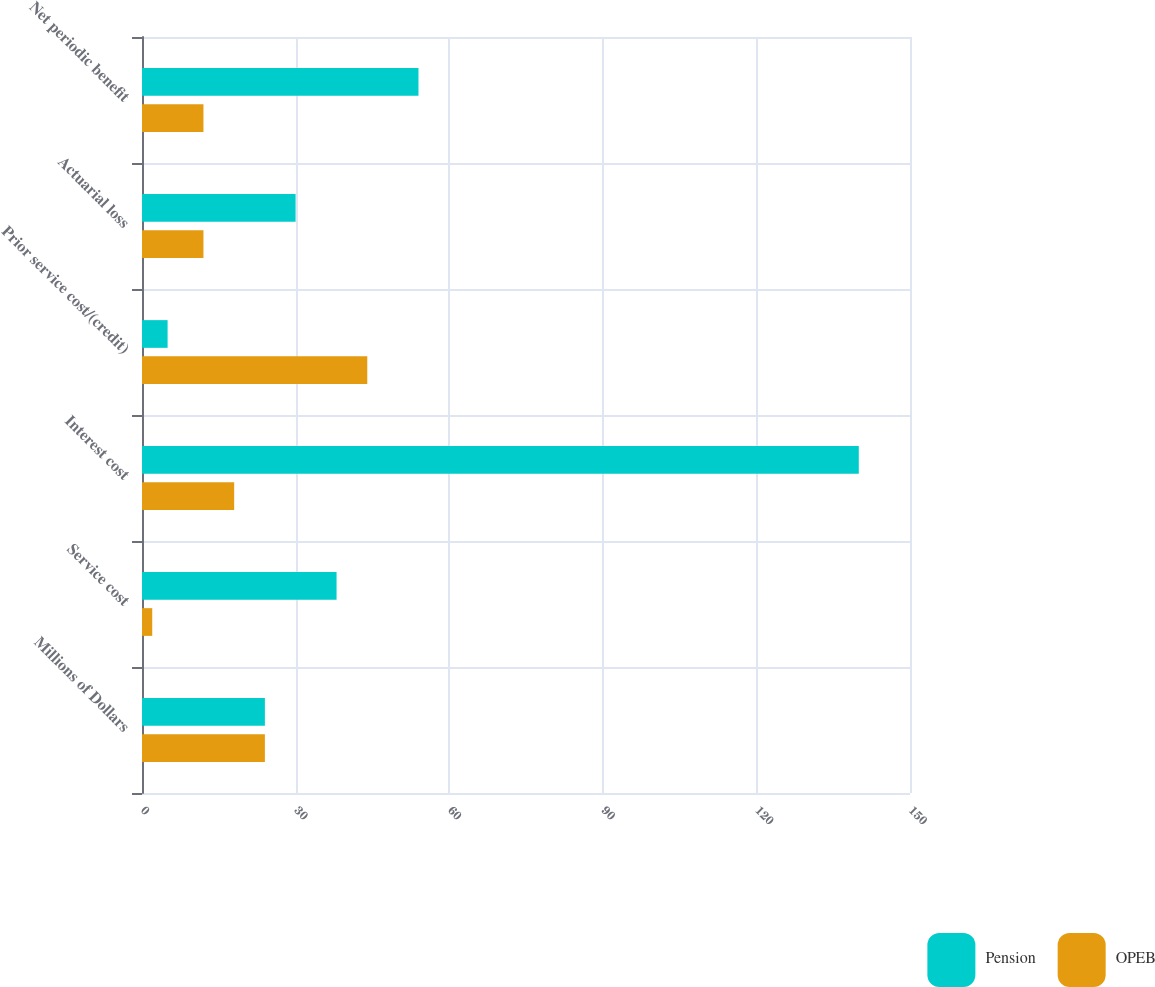Convert chart. <chart><loc_0><loc_0><loc_500><loc_500><stacked_bar_chart><ecel><fcel>Millions of Dollars<fcel>Service cost<fcel>Interest cost<fcel>Prior service cost/(credit)<fcel>Actuarial loss<fcel>Net periodic benefit<nl><fcel>Pension<fcel>24<fcel>38<fcel>140<fcel>5<fcel>30<fcel>54<nl><fcel>OPEB<fcel>24<fcel>2<fcel>18<fcel>44<fcel>12<fcel>12<nl></chart> 